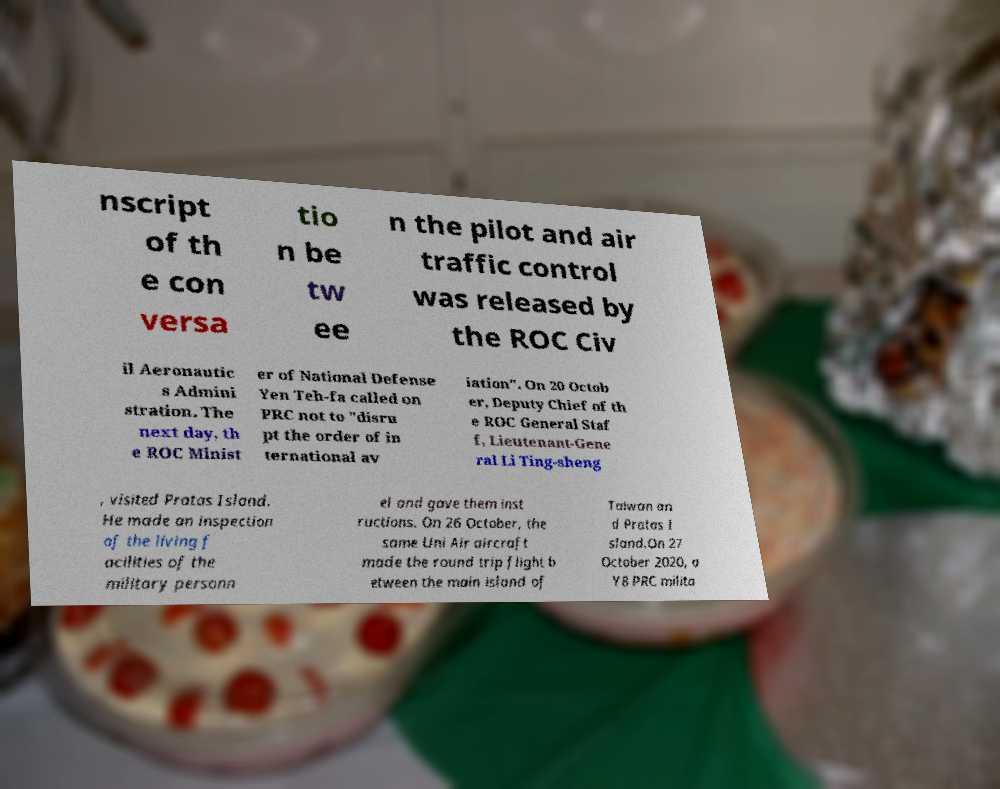I need the written content from this picture converted into text. Can you do that? nscript of th e con versa tio n be tw ee n the pilot and air traffic control was released by the ROC Civ il Aeronautic s Admini stration. The next day, th e ROC Minist er of National Defense Yen Teh-fa called on PRC not to "disru pt the order of in ternational av iation". On 20 Octob er, Deputy Chief of th e ROC General Staf f, Lieutenant-Gene ral Li Ting-sheng , visited Pratas Island. He made an inspection of the living f acilities of the military personn el and gave them inst ructions. On 26 October, the same Uni Air aircraft made the round trip flight b etween the main island of Taiwan an d Pratas I sland.On 27 October 2020, a Y8 PRC milita 